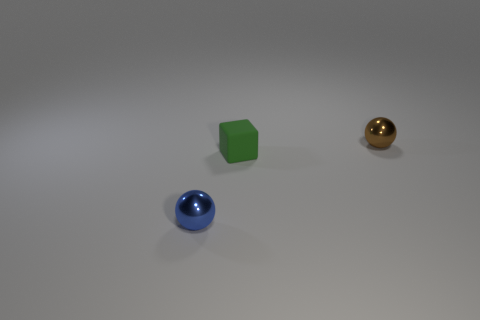Could you guess what material each object is made of? Based on the reflections and surface texture, the sphere on the right appears to be metallic, possibly brass or gold-colored metal, the cube looks like it could be made of matte plastic due to its consistent and non-reflective surface, and the sphere on the left seems to have a glossy finish, suggesting a glass or polished stone material. 